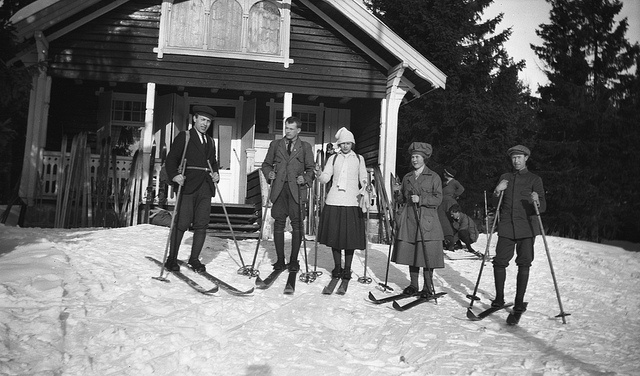Describe the objects in this image and their specific colors. I can see people in black, gray, darkgray, and lightgray tones, people in black, gray, darkgray, and lightgray tones, people in black, gray, darkgray, and gainsboro tones, people in black, lightgray, darkgray, and gray tones, and people in black, gray, darkgray, and lightgray tones in this image. 